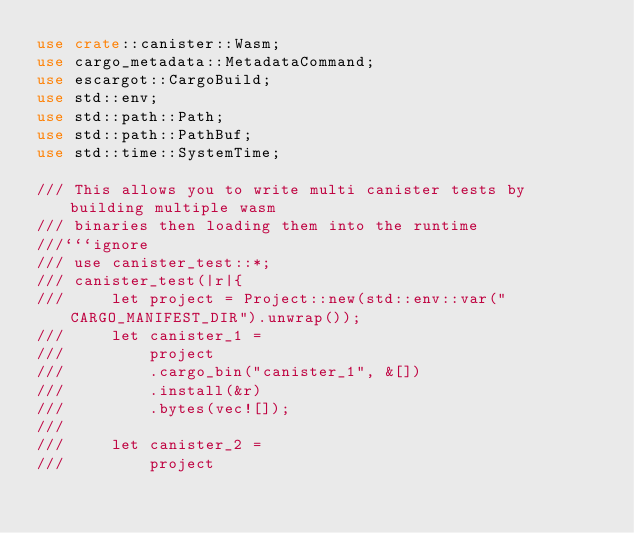Convert code to text. <code><loc_0><loc_0><loc_500><loc_500><_Rust_>use crate::canister::Wasm;
use cargo_metadata::MetadataCommand;
use escargot::CargoBuild;
use std::env;
use std::path::Path;
use std::path::PathBuf;
use std::time::SystemTime;

/// This allows you to write multi canister tests by building multiple wasm
/// binaries then loading them into the runtime
///```ignore
/// use canister_test::*;
/// canister_test(|r|{
///     let project = Project::new(std::env::var("CARGO_MANIFEST_DIR").unwrap());
///     let canister_1 =
///         project
///         .cargo_bin("canister_1", &[])
///         .install(&r)
///         .bytes(vec![]);
///
///     let canister_2 =
///         project</code> 